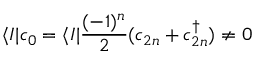<formula> <loc_0><loc_0><loc_500><loc_500>\langle I | c _ { 0 } = \langle I | { \frac { ( - 1 ) ^ { n } } { 2 } } ( c _ { 2 n } + c _ { 2 n } ^ { \dagger } ) \not = 0</formula> 